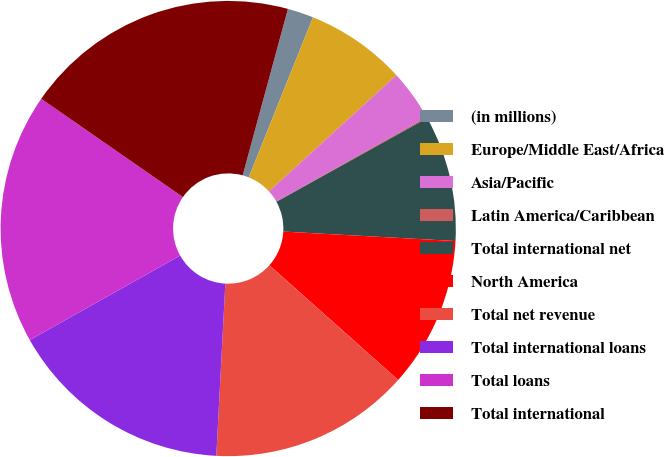Convert chart to OTSL. <chart><loc_0><loc_0><loc_500><loc_500><pie_chart><fcel>(in millions)<fcel>Europe/Middle East/Africa<fcel>Asia/Pacific<fcel>Latin America/Caribbean<fcel>Total international net<fcel>North America<fcel>Total net revenue<fcel>Total international loans<fcel>Total loans<fcel>Total international<nl><fcel>1.85%<fcel>7.16%<fcel>3.62%<fcel>0.08%<fcel>8.94%<fcel>10.71%<fcel>14.25%<fcel>16.02%<fcel>17.8%<fcel>19.57%<nl></chart> 